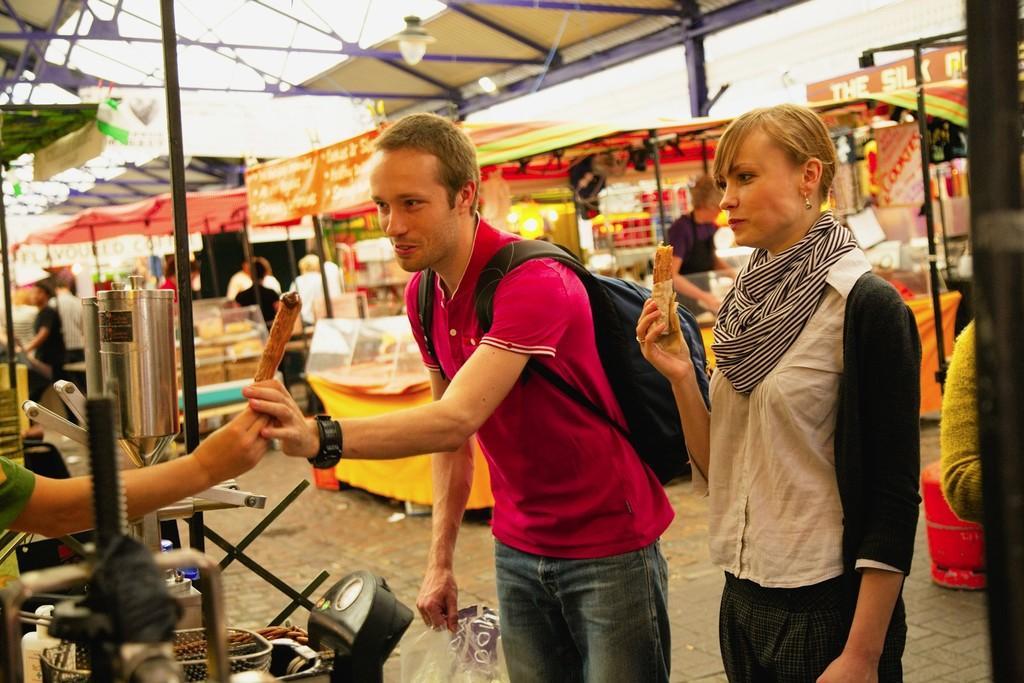Describe this image in one or two sentences. In this image there is a girl holding Frankie, beside that there is a boy taking Frankie from other hand, also there are so many food stalls at the back. 